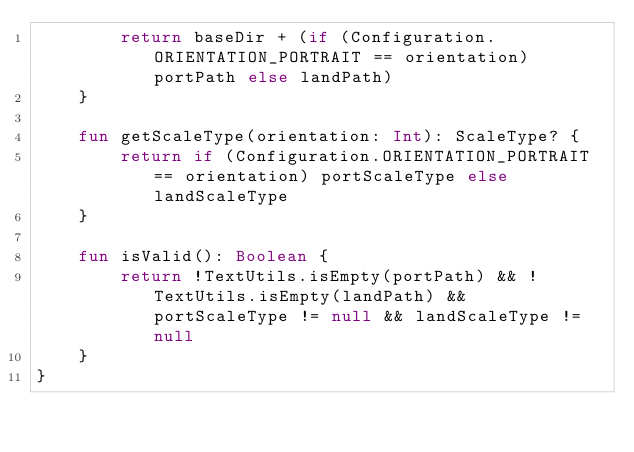<code> <loc_0><loc_0><loc_500><loc_500><_Kotlin_>        return baseDir + (if (Configuration.ORIENTATION_PORTRAIT == orientation) portPath else landPath)
    }

    fun getScaleType(orientation: Int): ScaleType? {
        return if (Configuration.ORIENTATION_PORTRAIT == orientation) portScaleType else landScaleType
    }

    fun isValid(): Boolean {
        return !TextUtils.isEmpty(portPath) && !TextUtils.isEmpty(landPath) && portScaleType != null && landScaleType != null
    }
}</code> 